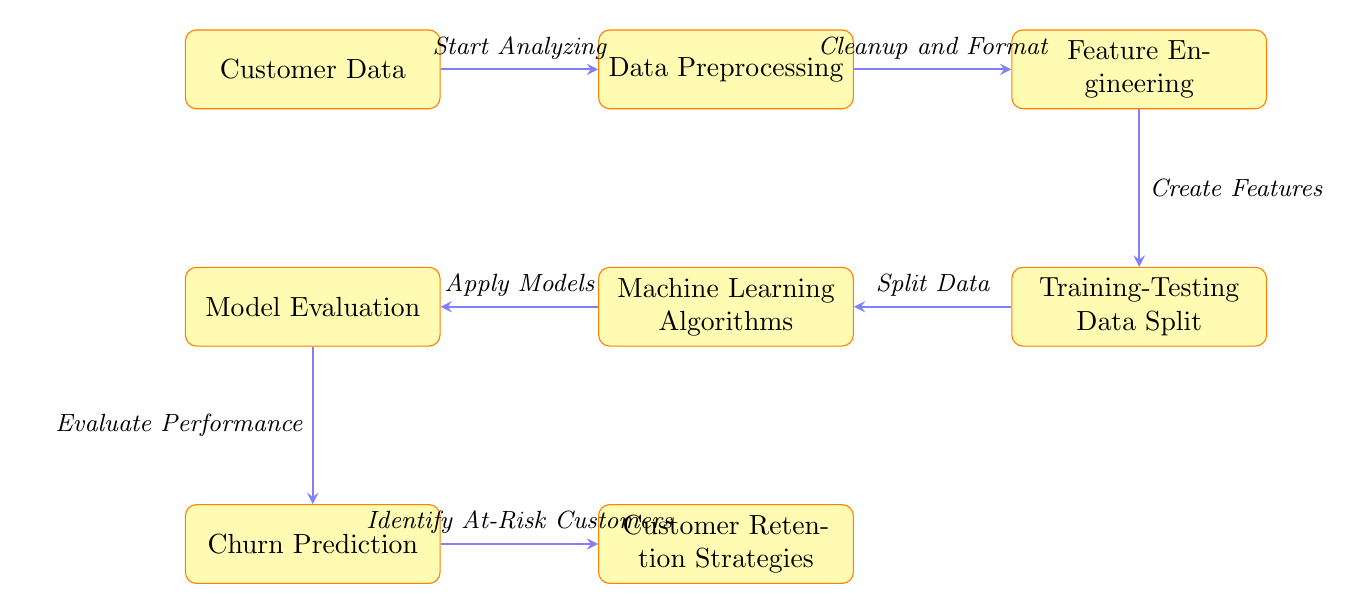What is the first step shown in the diagram? The first step in the diagram is represented by the node labeled "Customer Data". This is where the analysis begins by gathering relevant data from customers.
Answer: Customer Data How many main processes are identified in the diagram? The diagram contains a total of seven main processes, including the starting and ending nodes. Each process is represented by a separate node.
Answer: Seven What does the "Data Preprocessing" step involve? The "Data Preprocessing" step is indicated as the action that follows "Customer Data", and it specifies cleanup and formatting of the customer data to make it ready for further analysis.
Answer: Cleanup and Format Which process directly follows "Feature Engineering"? The process that directly follows "Feature Engineering" is the "Training-Testing Data Split". This step involves dividing the data into two subsets for model training and evaluation.
Answer: Training-Testing Data Split Which node leads into "Churn Prediction"? The node that leads into "Churn Prediction" is "Model Evaluation". This indicates that before making predictions, the developed model must be evaluated for its performance.
Answer: Model Evaluation After "Churn Prediction", what is the next step? The next step after "Churn Prediction" is the "Customer Retention Strategies". This step focuses on implementing strategies based on the predictions made regarding at-risk customers.
Answer: Customer Retention Strategies What type of algorithms are applied in the process? The type of algorithms applied in this diagram are referred to simply as "Machine Learning Algorithms", which are utilized to derive predictions from the prepared data.
Answer: Machine Learning Algorithms Which step emphasizes the evaluation of the model's performance? The step that emphasizes the evaluation of the model's performance is the "Model Evaluation", which assesses how well the model predicts churn.
Answer: Model Evaluation 